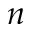<formula> <loc_0><loc_0><loc_500><loc_500>n</formula> 